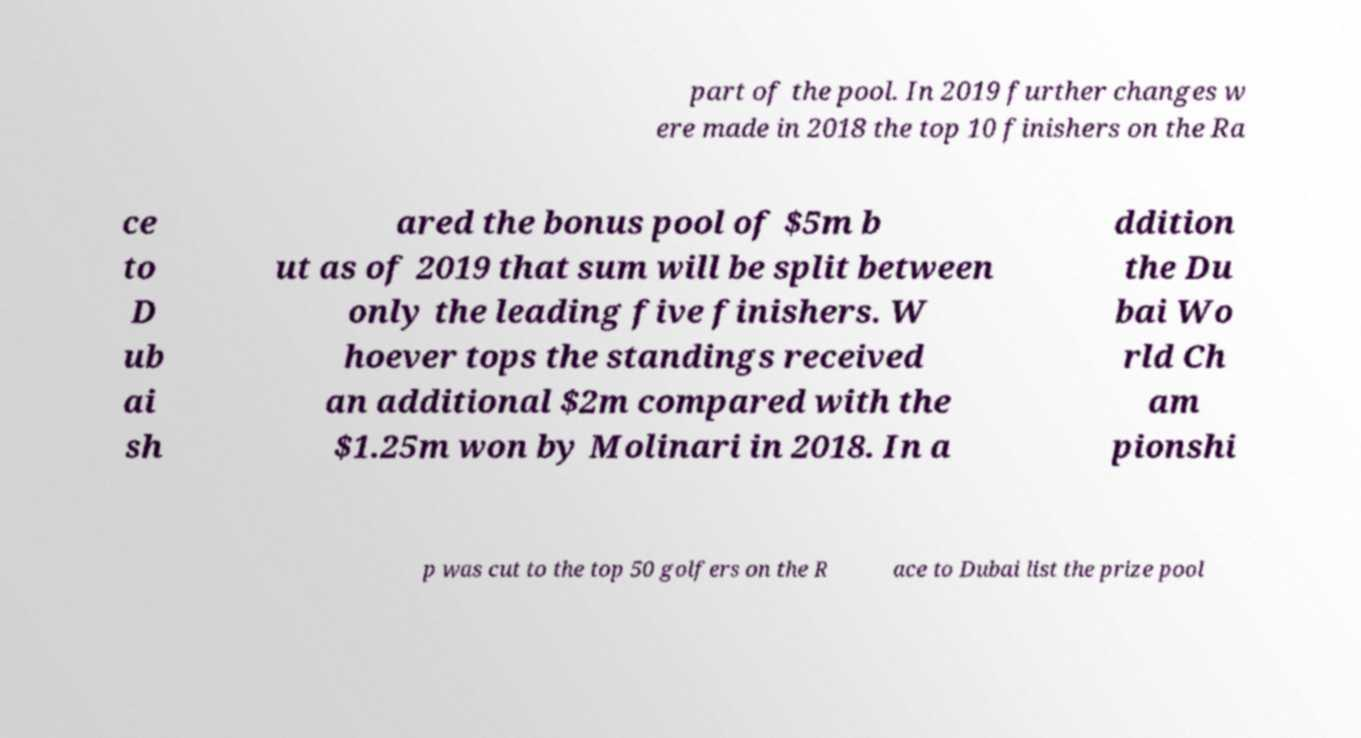What messages or text are displayed in this image? I need them in a readable, typed format. part of the pool. In 2019 further changes w ere made in 2018 the top 10 finishers on the Ra ce to D ub ai sh ared the bonus pool of $5m b ut as of 2019 that sum will be split between only the leading five finishers. W hoever tops the standings received an additional $2m compared with the $1.25m won by Molinari in 2018. In a ddition the Du bai Wo rld Ch am pionshi p was cut to the top 50 golfers on the R ace to Dubai list the prize pool 